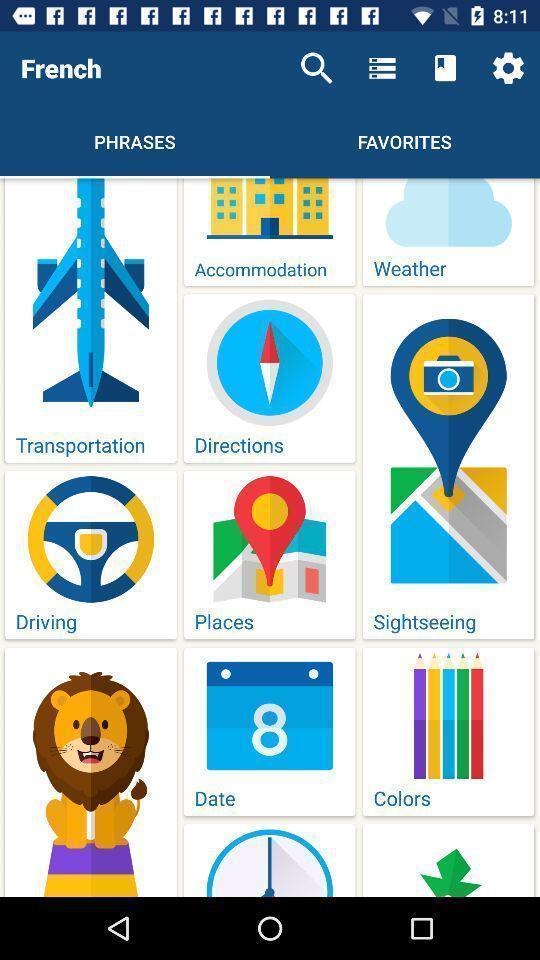Provide a description of this screenshot. Screen shows a page from a language learning app. 